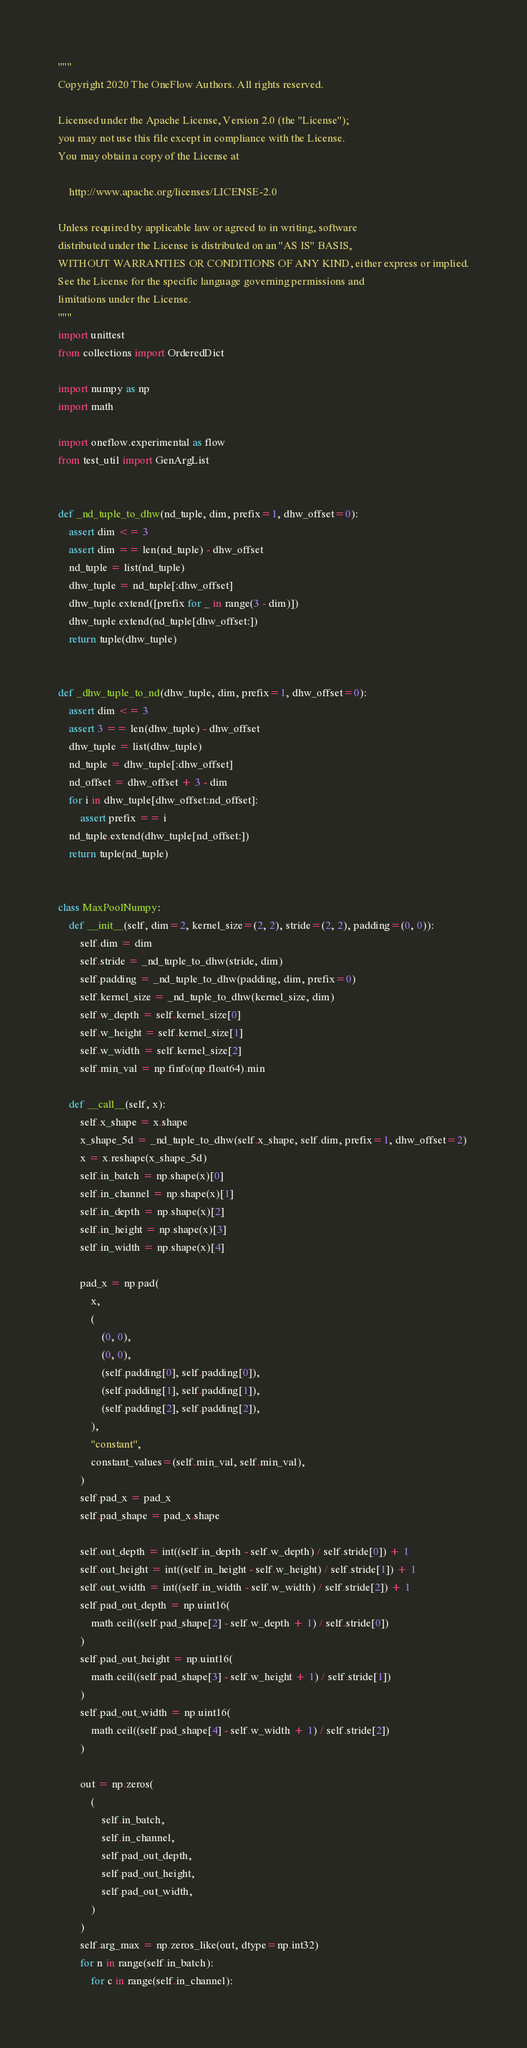<code> <loc_0><loc_0><loc_500><loc_500><_Python_>"""
Copyright 2020 The OneFlow Authors. All rights reserved.

Licensed under the Apache License, Version 2.0 (the "License");
you may not use this file except in compliance with the License.
You may obtain a copy of the License at

    http://www.apache.org/licenses/LICENSE-2.0

Unless required by applicable law or agreed to in writing, software
distributed under the License is distributed on an "AS IS" BASIS,
WITHOUT WARRANTIES OR CONDITIONS OF ANY KIND, either express or implied.
See the License for the specific language governing permissions and
limitations under the License.
"""
import unittest
from collections import OrderedDict

import numpy as np
import math

import oneflow.experimental as flow
from test_util import GenArgList


def _nd_tuple_to_dhw(nd_tuple, dim, prefix=1, dhw_offset=0):
    assert dim <= 3
    assert dim == len(nd_tuple) - dhw_offset
    nd_tuple = list(nd_tuple)
    dhw_tuple = nd_tuple[:dhw_offset]
    dhw_tuple.extend([prefix for _ in range(3 - dim)])
    dhw_tuple.extend(nd_tuple[dhw_offset:])
    return tuple(dhw_tuple)


def _dhw_tuple_to_nd(dhw_tuple, dim, prefix=1, dhw_offset=0):
    assert dim <= 3
    assert 3 == len(dhw_tuple) - dhw_offset
    dhw_tuple = list(dhw_tuple)
    nd_tuple = dhw_tuple[:dhw_offset]
    nd_offset = dhw_offset + 3 - dim
    for i in dhw_tuple[dhw_offset:nd_offset]:
        assert prefix == i
    nd_tuple.extend(dhw_tuple[nd_offset:])
    return tuple(nd_tuple)


class MaxPoolNumpy:
    def __init__(self, dim=2, kernel_size=(2, 2), stride=(2, 2), padding=(0, 0)):
        self.dim = dim
        self.stride = _nd_tuple_to_dhw(stride, dim)
        self.padding = _nd_tuple_to_dhw(padding, dim, prefix=0)
        self.kernel_size = _nd_tuple_to_dhw(kernel_size, dim)
        self.w_depth = self.kernel_size[0]
        self.w_height = self.kernel_size[1]
        self.w_width = self.kernel_size[2]
        self.min_val = np.finfo(np.float64).min

    def __call__(self, x):
        self.x_shape = x.shape
        x_shape_5d = _nd_tuple_to_dhw(self.x_shape, self.dim, prefix=1, dhw_offset=2)
        x = x.reshape(x_shape_5d)
        self.in_batch = np.shape(x)[0]
        self.in_channel = np.shape(x)[1]
        self.in_depth = np.shape(x)[2]
        self.in_height = np.shape(x)[3]
        self.in_width = np.shape(x)[4]

        pad_x = np.pad(
            x,
            (
                (0, 0),
                (0, 0),
                (self.padding[0], self.padding[0]),
                (self.padding[1], self.padding[1]),
                (self.padding[2], self.padding[2]),
            ),
            "constant",
            constant_values=(self.min_val, self.min_val),
        )
        self.pad_x = pad_x
        self.pad_shape = pad_x.shape

        self.out_depth = int((self.in_depth - self.w_depth) / self.stride[0]) + 1
        self.out_height = int((self.in_height - self.w_height) / self.stride[1]) + 1
        self.out_width = int((self.in_width - self.w_width) / self.stride[2]) + 1
        self.pad_out_depth = np.uint16(
            math.ceil((self.pad_shape[2] - self.w_depth + 1) / self.stride[0])
        )
        self.pad_out_height = np.uint16(
            math.ceil((self.pad_shape[3] - self.w_height + 1) / self.stride[1])
        )
        self.pad_out_width = np.uint16(
            math.ceil((self.pad_shape[4] - self.w_width + 1) / self.stride[2])
        )

        out = np.zeros(
            (
                self.in_batch,
                self.in_channel,
                self.pad_out_depth,
                self.pad_out_height,
                self.pad_out_width,
            )
        )
        self.arg_max = np.zeros_like(out, dtype=np.int32)
        for n in range(self.in_batch):
            for c in range(self.in_channel):</code> 